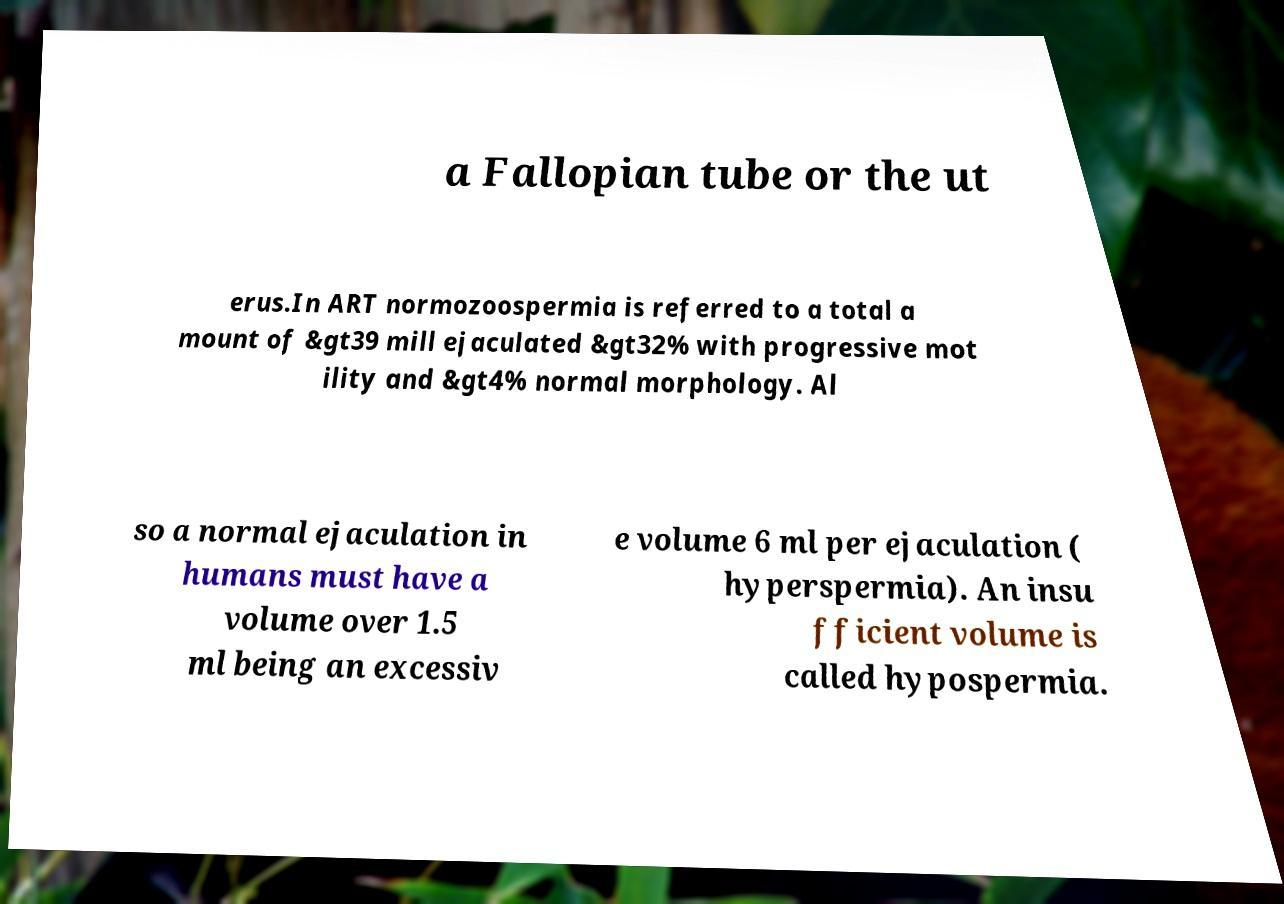There's text embedded in this image that I need extracted. Can you transcribe it verbatim? a Fallopian tube or the ut erus.In ART normozoospermia is referred to a total a mount of &gt39 mill ejaculated &gt32% with progressive mot ility and &gt4% normal morphology. Al so a normal ejaculation in humans must have a volume over 1.5 ml being an excessiv e volume 6 ml per ejaculation ( hyperspermia). An insu fficient volume is called hypospermia. 